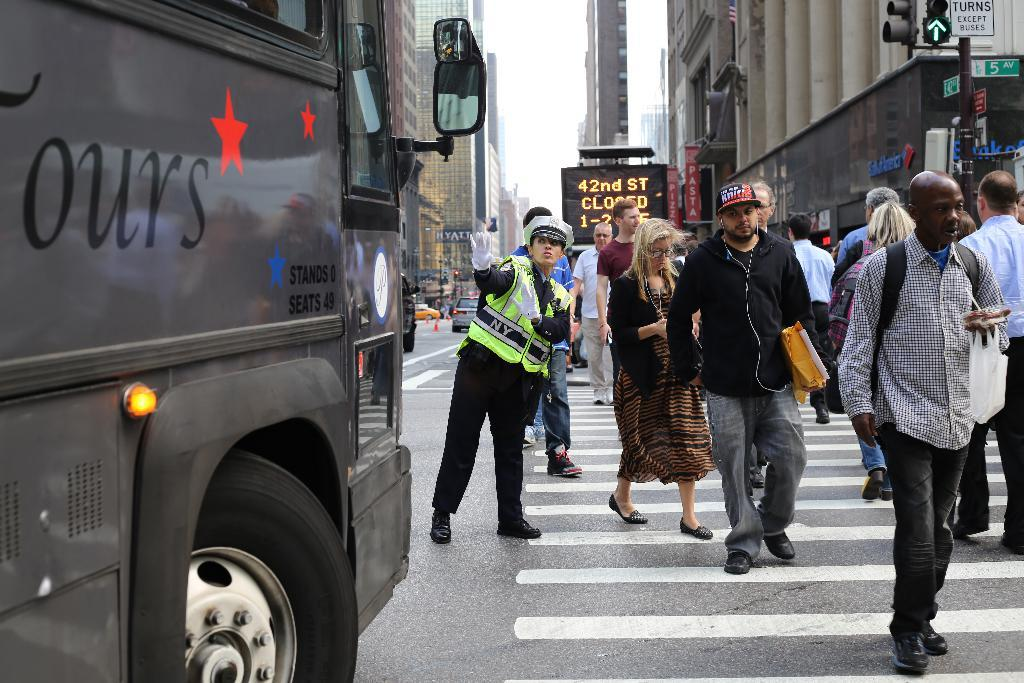What is happening on the road in the image? There are people on the road in the image. What else can be seen on the road besides people? There are vehicles in the image. What structures are visible in the background? There are buildings in the image. What other objects can be seen in the image? There are poles in the image, as well as other unspecified objects. What type of plantation can be seen in the image? There is no plantation present in the image. What industry is depicted in the image? The image does not depict any specific industry. 